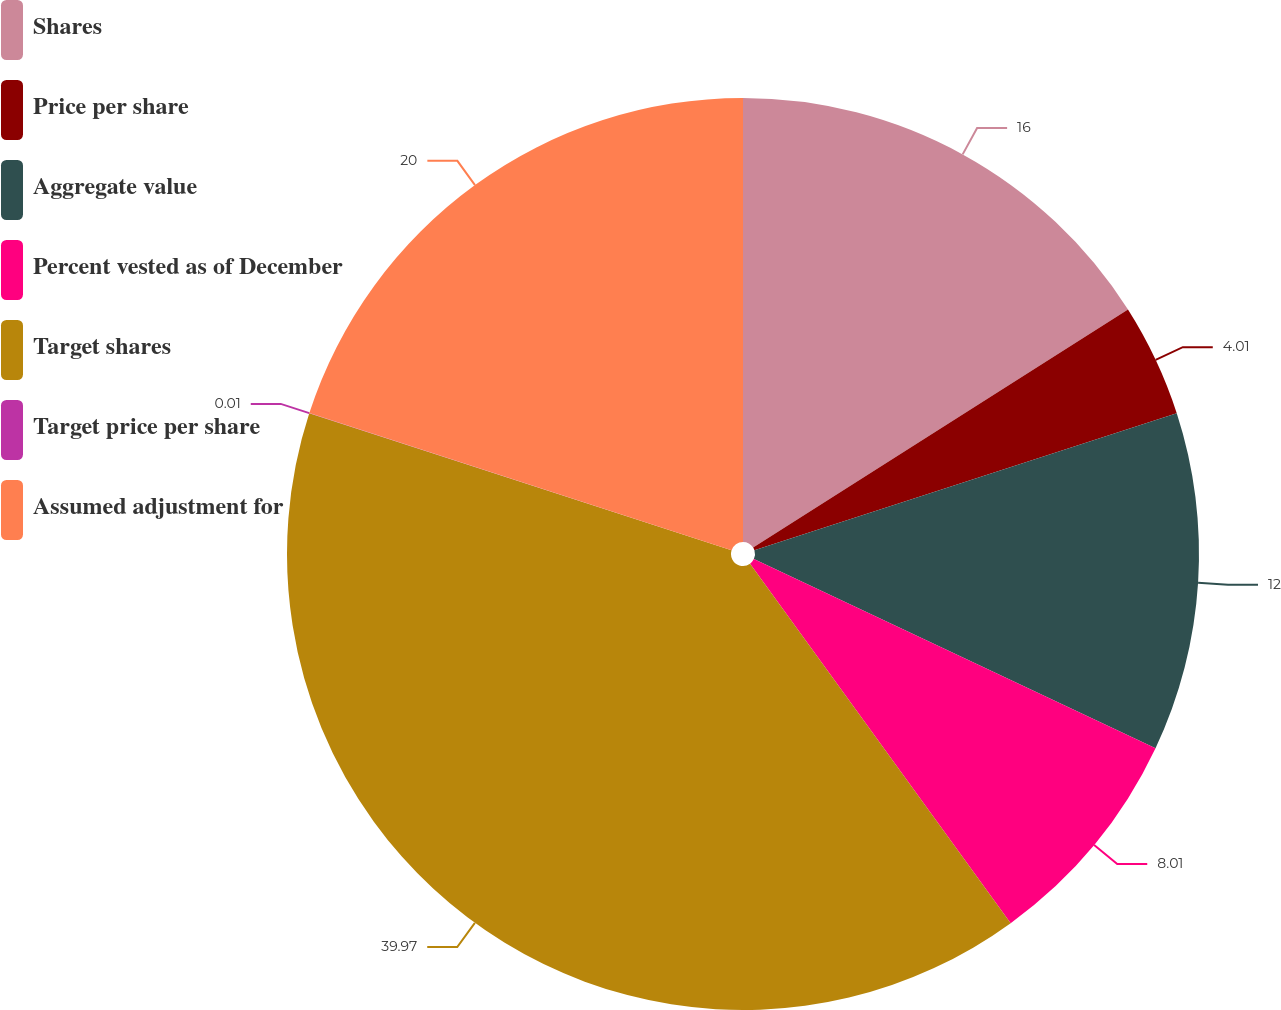Convert chart to OTSL. <chart><loc_0><loc_0><loc_500><loc_500><pie_chart><fcel>Shares<fcel>Price per share<fcel>Aggregate value<fcel>Percent vested as of December<fcel>Target shares<fcel>Target price per share<fcel>Assumed adjustment for<nl><fcel>16.0%<fcel>4.01%<fcel>12.0%<fcel>8.01%<fcel>39.98%<fcel>0.01%<fcel>20.0%<nl></chart> 